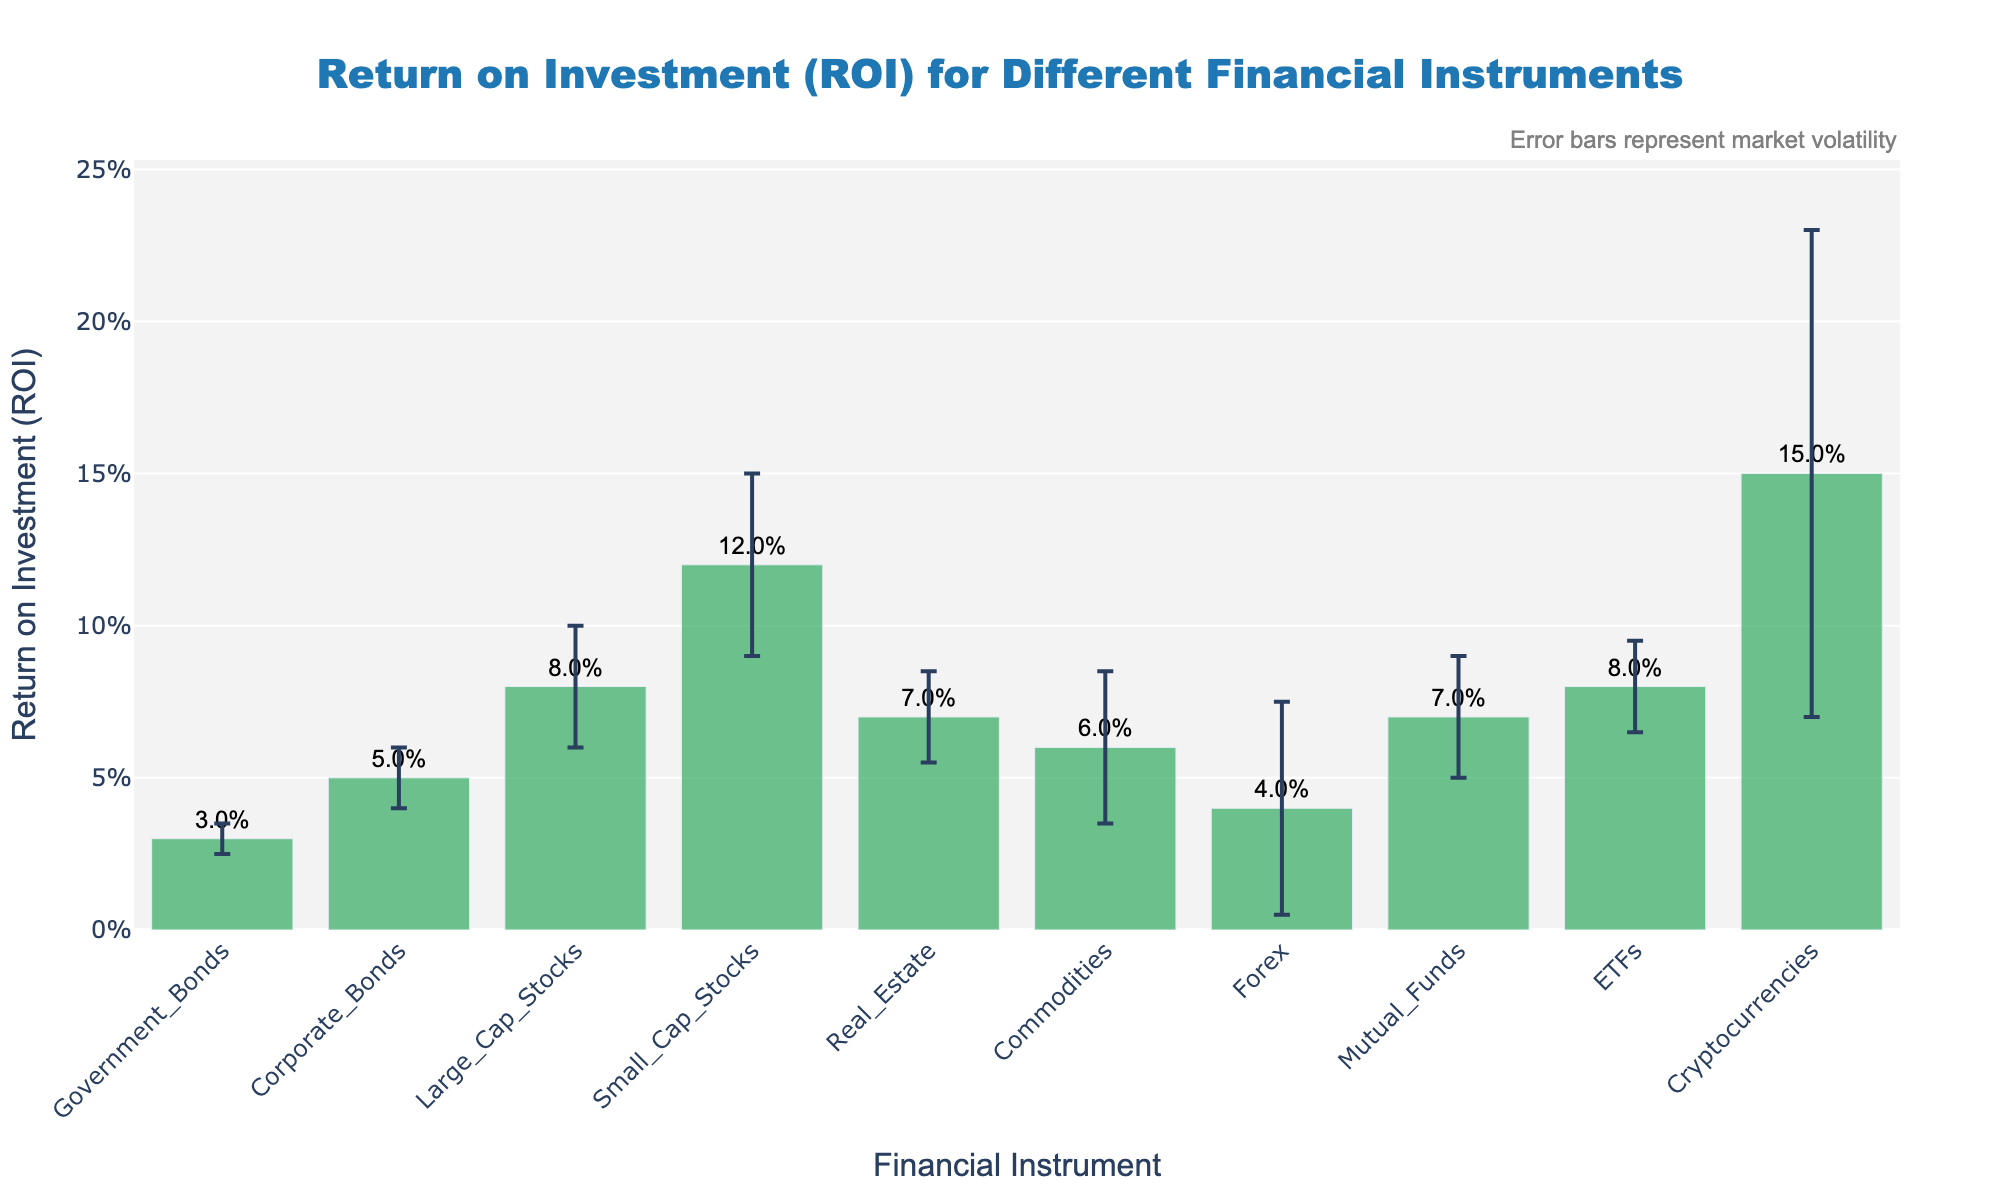What is the title of the figure? The title of the figure is positioned at the top center and is easily readable in large font size.
Answer: Return on Investment (ROI) for Different Financial Instruments What does the y-axis represent? The y-axis represents the Return on Investment (ROI) in percentage format.
Answer: Return on Investment (ROI) Which financial instrument has the highest ROI? By comparing the bar heights, the tallest bar represents the highest ROI, which corresponds to Cryptocurrencies.
Answer: Cryptocurrencies What is the market volatility for Large Cap Stocks? Market volatility is represented by the error bars. For Large Cap Stocks, the error bar value is 0.02.
Answer: 0.02 Comparing Government Bonds and Corporate Bonds, which one has a higher ROI and by how much? Government Bonds have an ROI of 0.03, and Corporate Bonds have an ROI of 0.05. The difference in ROI is calculated as 0.05 - 0.03.
Answer: Corporate Bonds by 0.02 What can you infer about the ROI and market volatility of Cryptocurrencies compared to other instruments? Cryptocurrencies have the highest ROI of 0.15 and also the highest market volatility with an error bar of 0.08, indicating a higher risk-return profile compared to other financial instruments.
Answer: High ROI and high market volatility Which financial instrument exhibits the lowest market volatility? The shortest error bars indicate the lowest market volatility. Government Bonds have the shortest error bars at 0.005.
Answer: Government Bonds How does the ROI of Mutual Funds compare to that of Real Estate? Both Mutual Funds and Real Estate have an ROI of 0.07, indicating they have the same ROI.
Answer: Equal Between ETFs and Forex, which has greater market volatility? Forex has an error bar of 0.035, while ETFs have an error bar of 0.015. Comparing the two, Forex has greater market volatility.
Answer: Forex If you were to choose a financial instrument with moderate ROI and relatively lower market volatility, which one would you pick? By examining the ROI and the error bars, ETFs have a moderate ROI of 0.08 and relatively lower market volatility with an error bar of 0.015.
Answer: ETFs 